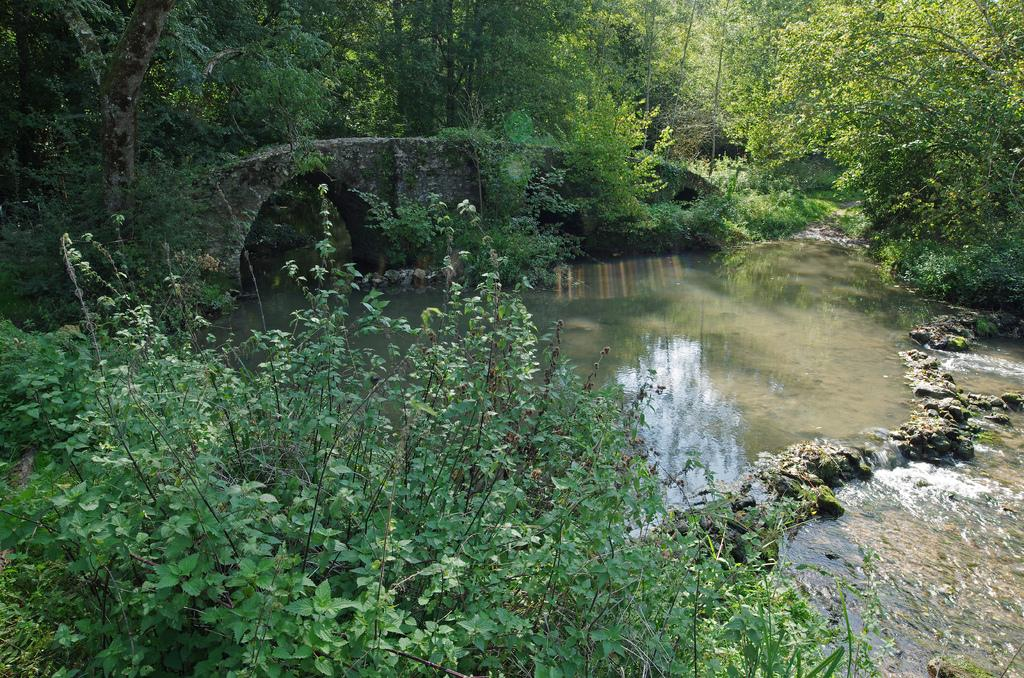What types of vegetation are present in the image? The image contains plants and trees. What can be seen in the center of the image? There is water in the center of the image. Is there any man-made structure visible in the image? Yes, there is a bridge in the image. What type of linen is draped over the goat in the image? There is no goat or linen present in the image. How many seats can be seen on the bridge in the image? There are no seats visible on the bridge in the image. 